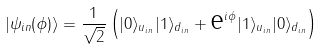Convert formula to latex. <formula><loc_0><loc_0><loc_500><loc_500>| \psi _ { i n } ( \phi ) \rangle = \frac { 1 } { \sqrt { 2 } } \left ( | 0 \rangle _ { u _ { i n } } | 1 \rangle _ { d _ { i n } } + { \text  e}^{i\phi}|1\rangle_{u_{in} } | 0 \rangle _ { d _ { i n } } \right )</formula> 